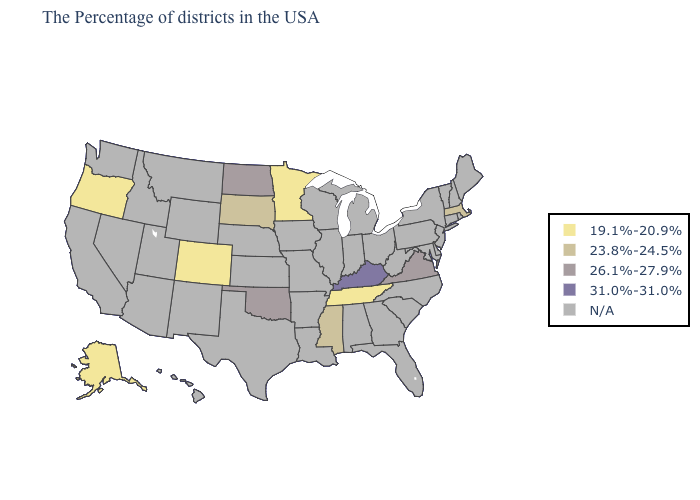What is the lowest value in the West?
Write a very short answer. 19.1%-20.9%. Among the states that border New York , which have the highest value?
Quick response, please. Massachusetts. Name the states that have a value in the range 19.1%-20.9%?
Quick response, please. Tennessee, Minnesota, Colorado, Oregon, Alaska. Does Virginia have the lowest value in the USA?
Quick response, please. No. What is the value of Oklahoma?
Quick response, please. 26.1%-27.9%. What is the value of Iowa?
Concise answer only. N/A. Which states have the lowest value in the MidWest?
Quick response, please. Minnesota. Which states have the lowest value in the USA?
Write a very short answer. Tennessee, Minnesota, Colorado, Oregon, Alaska. What is the value of New Jersey?
Be succinct. N/A. Which states have the lowest value in the Northeast?
Give a very brief answer. Massachusetts. Name the states that have a value in the range 31.0%-31.0%?
Be succinct. Kentucky. What is the lowest value in states that border New Hampshire?
Short answer required. 23.8%-24.5%. Name the states that have a value in the range 19.1%-20.9%?
Quick response, please. Tennessee, Minnesota, Colorado, Oregon, Alaska. 